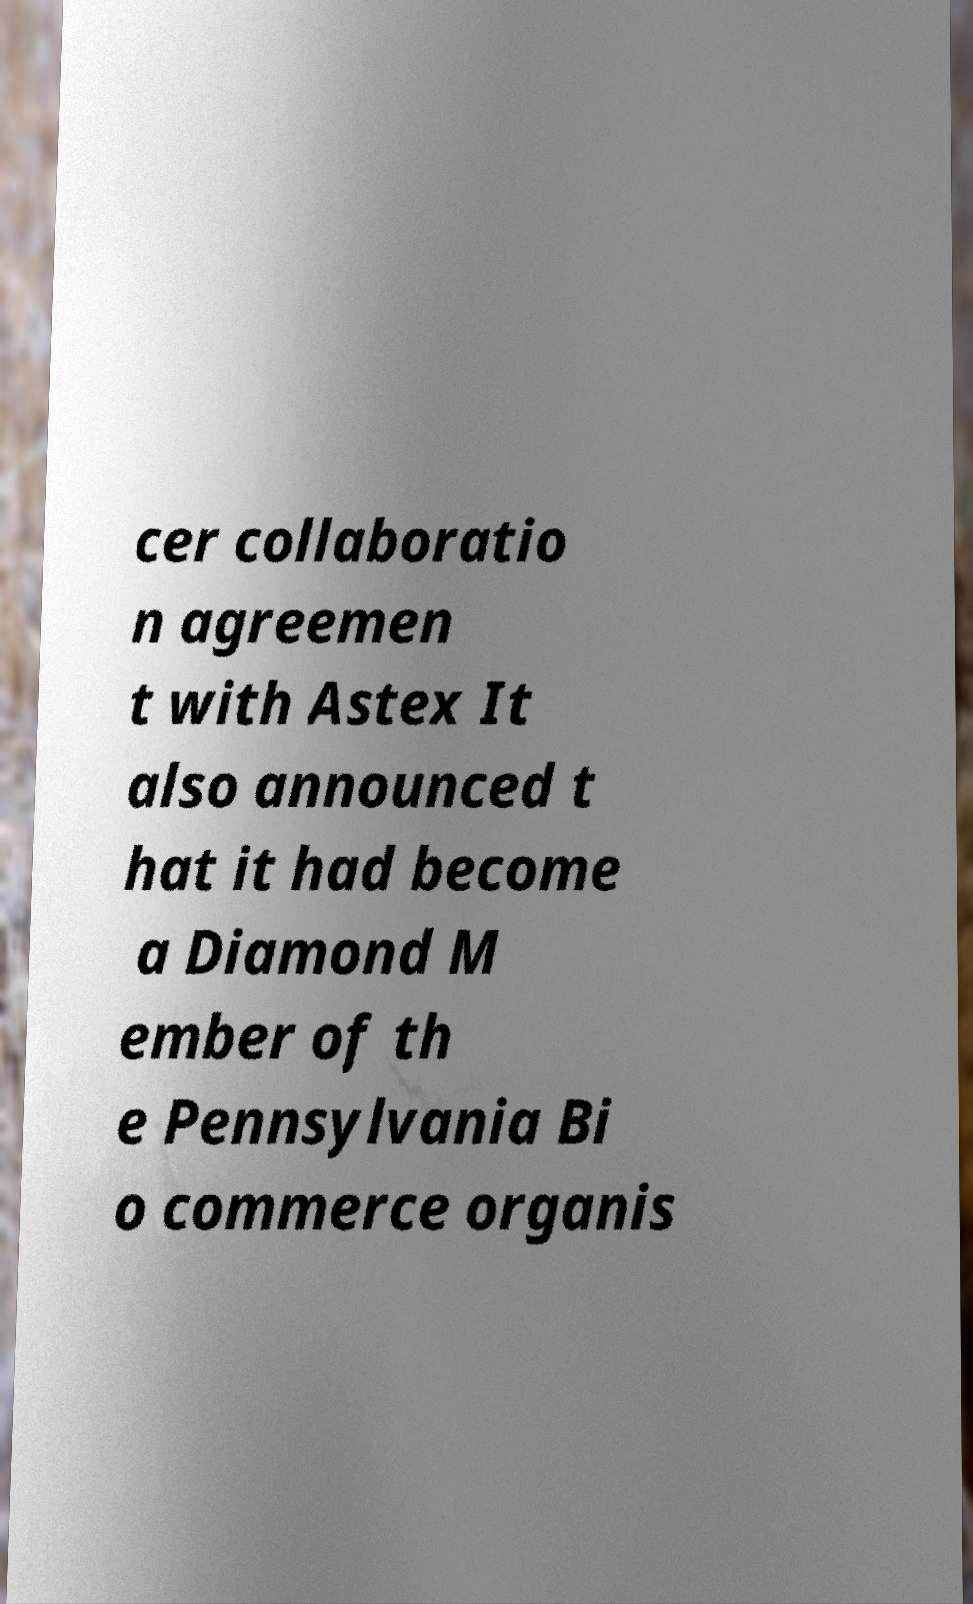Could you extract and type out the text from this image? cer collaboratio n agreemen t with Astex It also announced t hat it had become a Diamond M ember of th e Pennsylvania Bi o commerce organis 